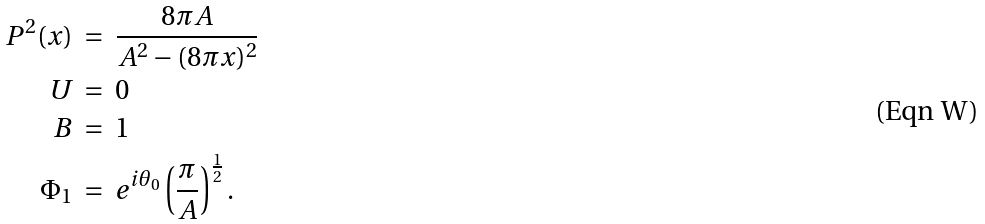Convert formula to latex. <formula><loc_0><loc_0><loc_500><loc_500>P ^ { 2 } ( x ) \ & = \ \frac { 8 \pi A } { A ^ { 2 } - ( 8 \pi x ) ^ { 2 } } \\ U \ & = \ 0 \\ B \ & = \ 1 \\ \Phi _ { 1 } \ & = \ e ^ { i \theta _ { 0 } } \left ( \frac { \pi } { A } \right ) ^ { \frac { 1 } { 2 } } .</formula> 